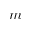<formula> <loc_0><loc_0><loc_500><loc_500>m</formula> 